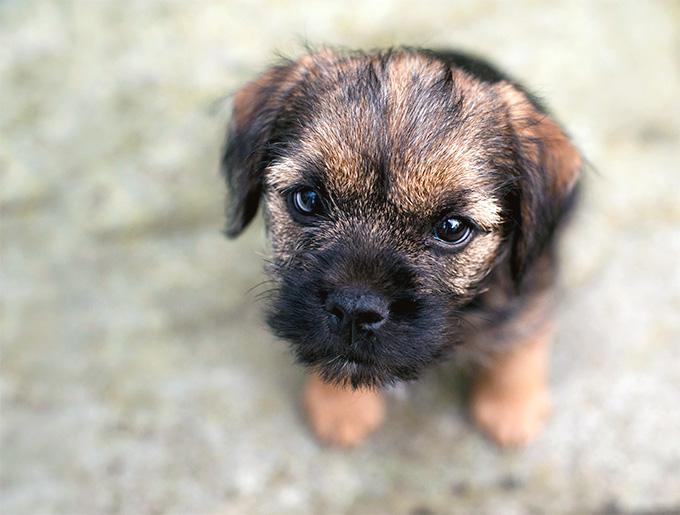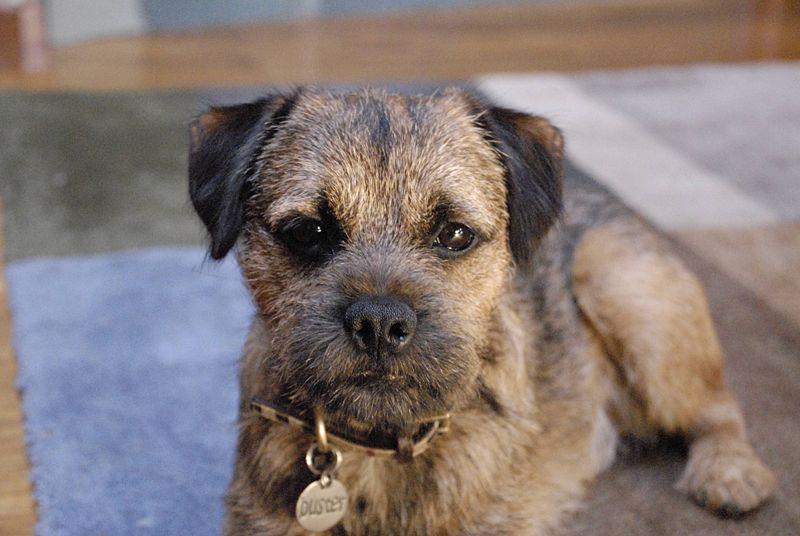The first image is the image on the left, the second image is the image on the right. Examine the images to the left and right. Is the description "A collar is visible around the neck of the dog in the right image." accurate? Answer yes or no. Yes. 